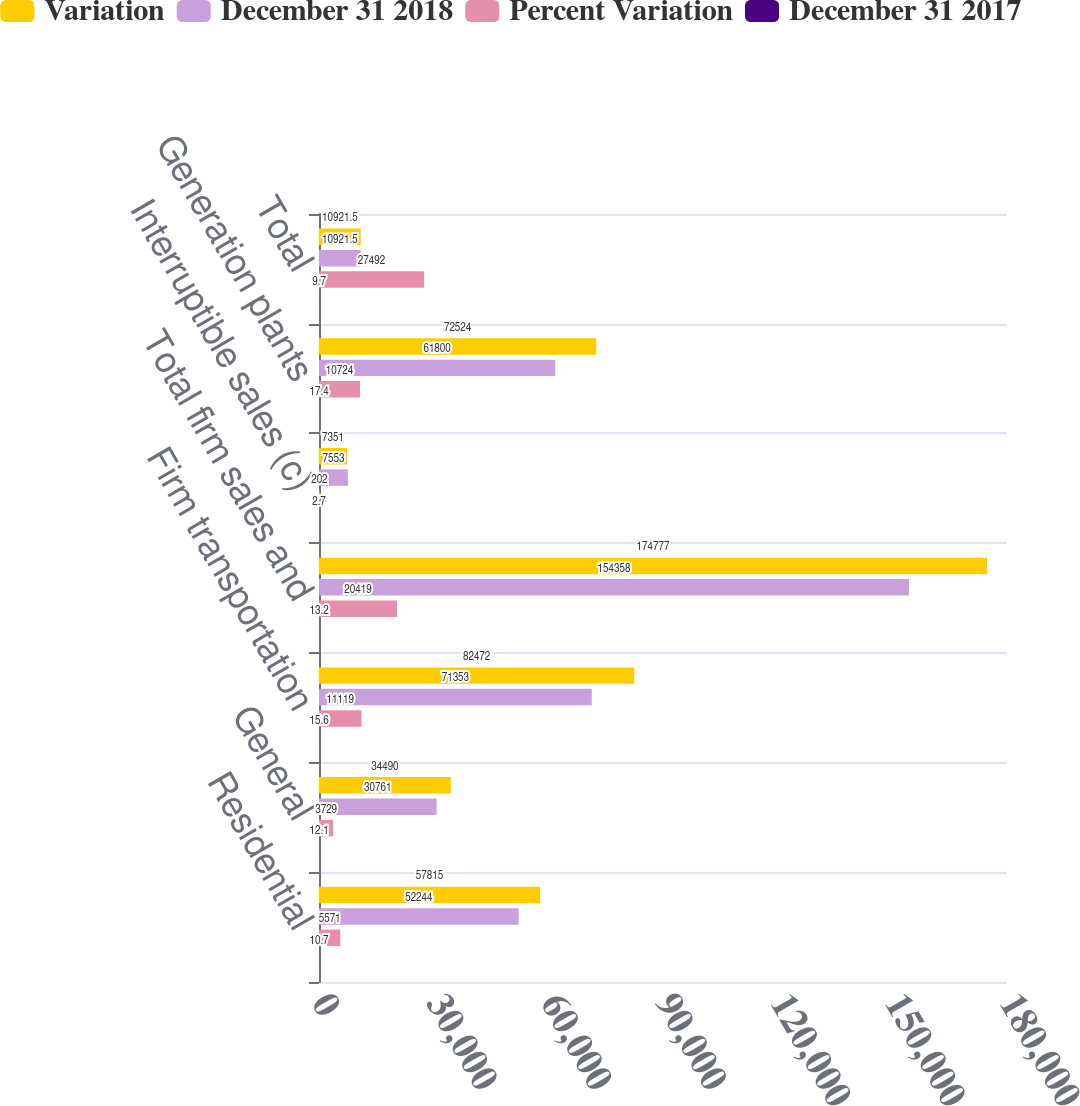<chart> <loc_0><loc_0><loc_500><loc_500><stacked_bar_chart><ecel><fcel>Residential<fcel>General<fcel>Firm transportation<fcel>Total firm sales and<fcel>Interruptible sales (c)<fcel>Generation plants<fcel>Total<nl><fcel>Variation<fcel>57815<fcel>34490<fcel>82472<fcel>174777<fcel>7351<fcel>72524<fcel>10921.5<nl><fcel>December 31 2018<fcel>52244<fcel>30761<fcel>71353<fcel>154358<fcel>7553<fcel>61800<fcel>10921.5<nl><fcel>Percent Variation<fcel>5571<fcel>3729<fcel>11119<fcel>20419<fcel>202<fcel>10724<fcel>27492<nl><fcel>December 31 2017<fcel>10.7<fcel>12.1<fcel>15.6<fcel>13.2<fcel>2.7<fcel>17.4<fcel>9.7<nl></chart> 